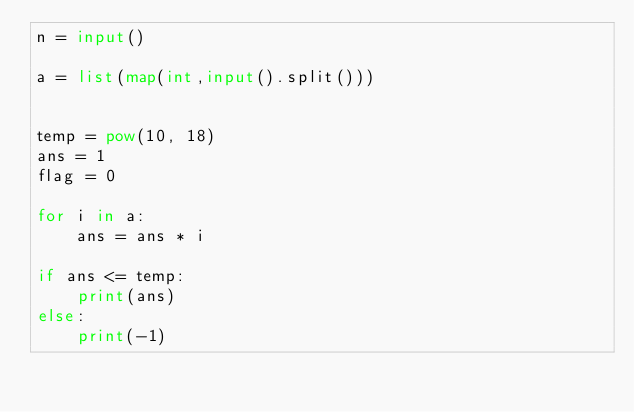<code> <loc_0><loc_0><loc_500><loc_500><_Python_>n = input()

a = list(map(int,input().split()))


temp = pow(10, 18)
ans = 1
flag = 0

for i in a:
    ans = ans * i

if ans <= temp:
    print(ans)
else:
    print(-1)
</code> 